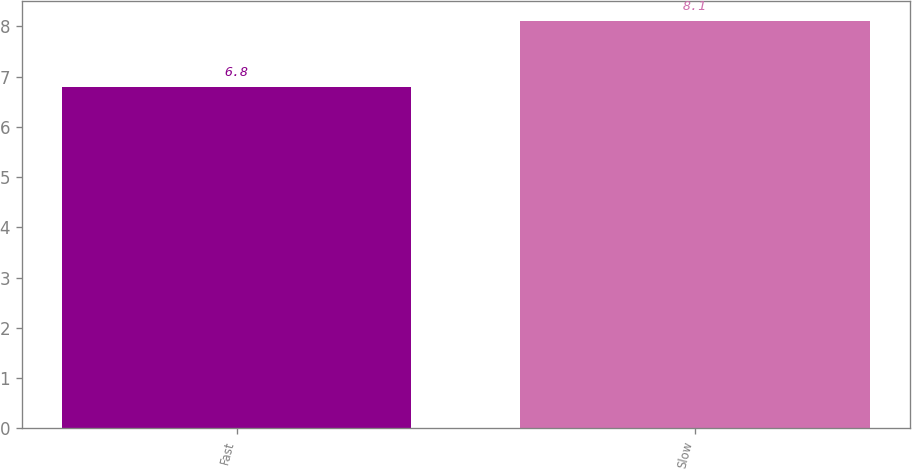<chart> <loc_0><loc_0><loc_500><loc_500><bar_chart><fcel>Fast<fcel>Slow<nl><fcel>6.8<fcel>8.1<nl></chart> 